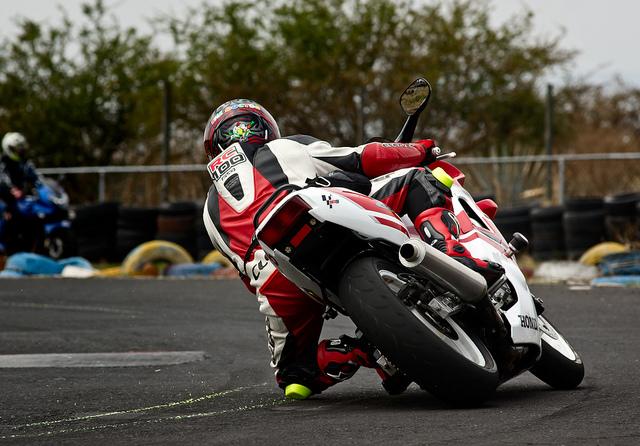Is the motorcycle leaning?
Give a very brief answer. Yes. Is he carrying an umbrella?
Answer briefly. No. Is this a dangerous activity?
Concise answer only. Yes. 